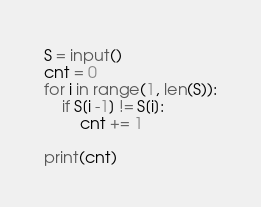Convert code to text. <code><loc_0><loc_0><loc_500><loc_500><_Python_>S = input()
cnt = 0
for i in range(1, len(S)):
    if S[i -1] != S[i]:
        cnt += 1

print(cnt)</code> 